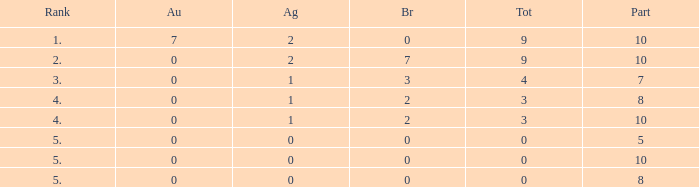What is the top gold figure with a silver figure below 1 and a total figure below 0? None. 